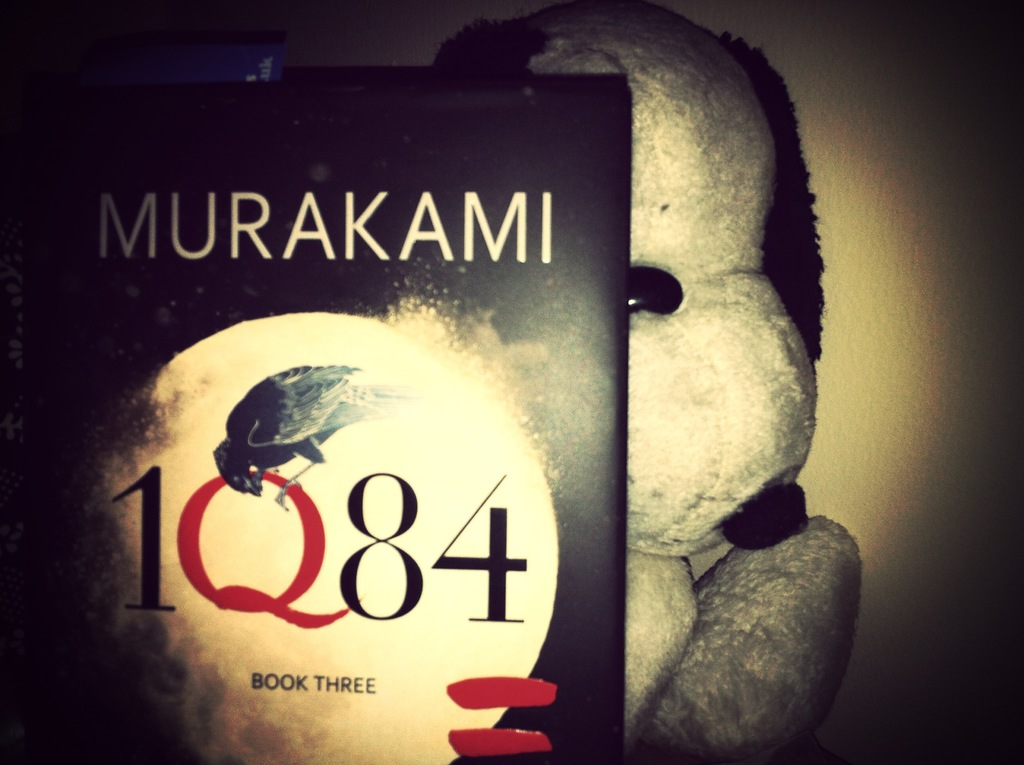What literary themes does '1Q84 Book Three' explore, and how is it visually represented on the cover? The novel delves into themes of dystopia, alternate reality, and complex human relationships. The cover visualizes these themes through the mysterious raven and the moon, symbolizing the enigmatic and otherworldly aspects of the story. 